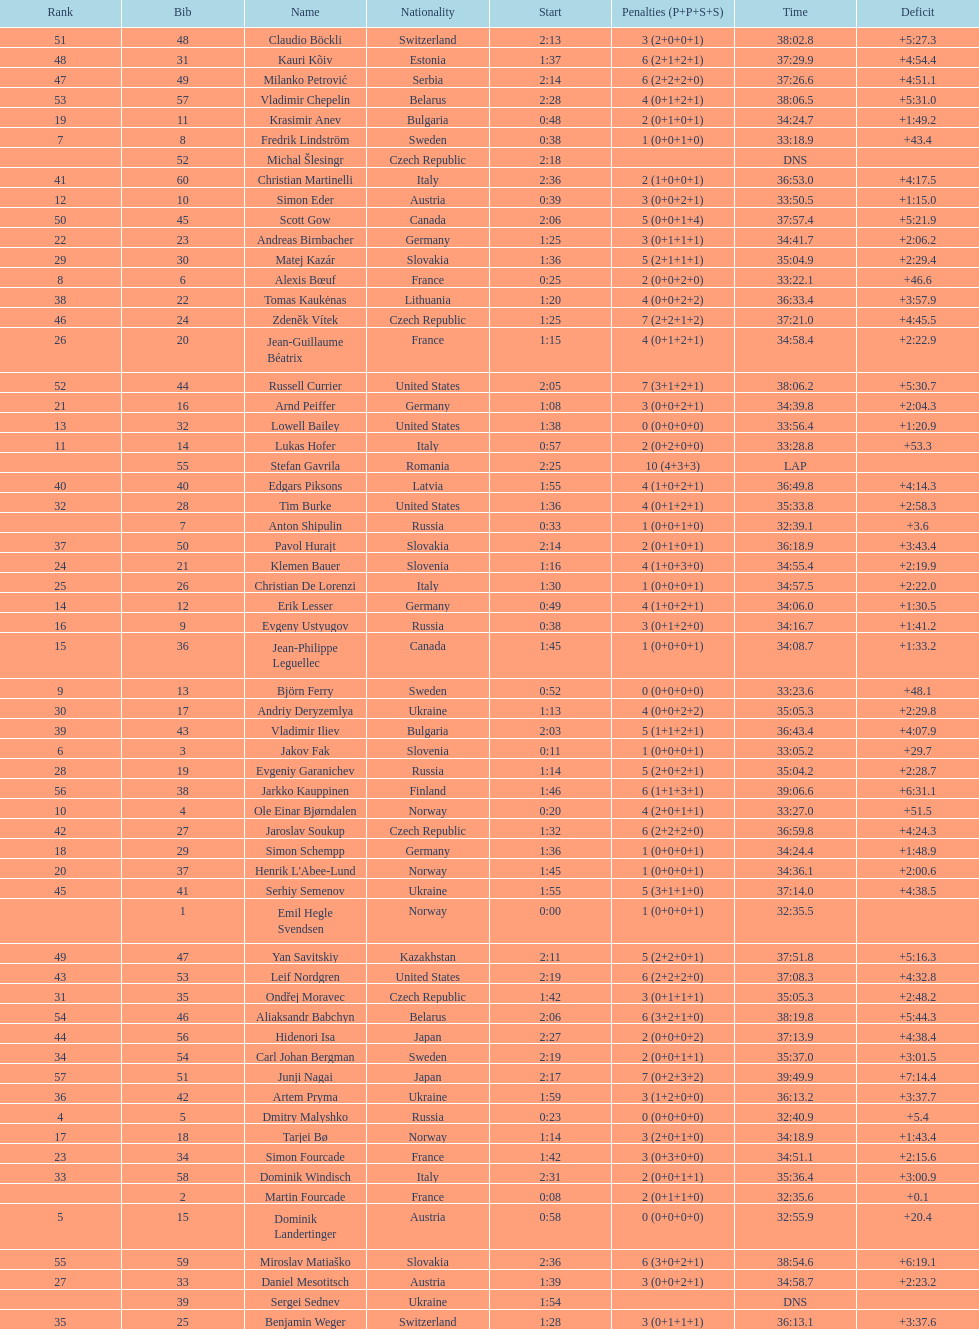What is the number of russian participants? 4. Write the full table. {'header': ['Rank', 'Bib', 'Name', 'Nationality', 'Start', 'Penalties (P+P+S+S)', 'Time', 'Deficit'], 'rows': [['51', '48', 'Claudio Böckli', 'Switzerland', '2:13', '3 (2+0+0+1)', '38:02.8', '+5:27.3'], ['48', '31', 'Kauri Kõiv', 'Estonia', '1:37', '6 (2+1+2+1)', '37:29.9', '+4:54.4'], ['47', '49', 'Milanko Petrović', 'Serbia', '2:14', '6 (2+2+2+0)', '37:26.6', '+4:51.1'], ['53', '57', 'Vladimir Chepelin', 'Belarus', '2:28', '4 (0+1+2+1)', '38:06.5', '+5:31.0'], ['19', '11', 'Krasimir Anev', 'Bulgaria', '0:48', '2 (0+1+0+1)', '34:24.7', '+1:49.2'], ['7', '8', 'Fredrik Lindström', 'Sweden', '0:38', '1 (0+0+1+0)', '33:18.9', '+43.4'], ['', '52', 'Michal Šlesingr', 'Czech Republic', '2:18', '', 'DNS', ''], ['41', '60', 'Christian Martinelli', 'Italy', '2:36', '2 (1+0+0+1)', '36:53.0', '+4:17.5'], ['12', '10', 'Simon Eder', 'Austria', '0:39', '3 (0+0+2+1)', '33:50.5', '+1:15.0'], ['50', '45', 'Scott Gow', 'Canada', '2:06', '5 (0+0+1+4)', '37:57.4', '+5:21.9'], ['22', '23', 'Andreas Birnbacher', 'Germany', '1:25', '3 (0+1+1+1)', '34:41.7', '+2:06.2'], ['29', '30', 'Matej Kazár', 'Slovakia', '1:36', '5 (2+1+1+1)', '35:04.9', '+2:29.4'], ['8', '6', 'Alexis Bœuf', 'France', '0:25', '2 (0+0+2+0)', '33:22.1', '+46.6'], ['38', '22', 'Tomas Kaukėnas', 'Lithuania', '1:20', '4 (0+0+2+2)', '36:33.4', '+3:57.9'], ['46', '24', 'Zdeněk Vítek', 'Czech Republic', '1:25', '7 (2+2+1+2)', '37:21.0', '+4:45.5'], ['26', '20', 'Jean-Guillaume Béatrix', 'France', '1:15', '4 (0+1+2+1)', '34:58.4', '+2:22.9'], ['52', '44', 'Russell Currier', 'United States', '2:05', '7 (3+1+2+1)', '38:06.2', '+5:30.7'], ['21', '16', 'Arnd Peiffer', 'Germany', '1:08', '3 (0+0+2+1)', '34:39.8', '+2:04.3'], ['13', '32', 'Lowell Bailey', 'United States', '1:38', '0 (0+0+0+0)', '33:56.4', '+1:20.9'], ['11', '14', 'Lukas Hofer', 'Italy', '0:57', '2 (0+2+0+0)', '33:28.8', '+53.3'], ['', '55', 'Stefan Gavrila', 'Romania', '2:25', '10 (4+3+3)', 'LAP', ''], ['40', '40', 'Edgars Piksons', 'Latvia', '1:55', '4 (1+0+2+1)', '36:49.8', '+4:14.3'], ['32', '28', 'Tim Burke', 'United States', '1:36', '4 (0+1+2+1)', '35:33.8', '+2:58.3'], ['', '7', 'Anton Shipulin', 'Russia', '0:33', '1 (0+0+1+0)', '32:39.1', '+3.6'], ['37', '50', 'Pavol Hurajt', 'Slovakia', '2:14', '2 (0+1+0+1)', '36:18.9', '+3:43.4'], ['24', '21', 'Klemen Bauer', 'Slovenia', '1:16', '4 (1+0+3+0)', '34:55.4', '+2:19.9'], ['25', '26', 'Christian De Lorenzi', 'Italy', '1:30', '1 (0+0+0+1)', '34:57.5', '+2:22.0'], ['14', '12', 'Erik Lesser', 'Germany', '0:49', '4 (1+0+2+1)', '34:06.0', '+1:30.5'], ['16', '9', 'Evgeny Ustyugov', 'Russia', '0:38', '3 (0+1+2+0)', '34:16.7', '+1:41.2'], ['15', '36', 'Jean-Philippe Leguellec', 'Canada', '1:45', '1 (0+0+0+1)', '34:08.7', '+1:33.2'], ['9', '13', 'Björn Ferry', 'Sweden', '0:52', '0 (0+0+0+0)', '33:23.6', '+48.1'], ['30', '17', 'Andriy Deryzemlya', 'Ukraine', '1:13', '4 (0+0+2+2)', '35:05.3', '+2:29.8'], ['39', '43', 'Vladimir Iliev', 'Bulgaria', '2:03', '5 (1+1+2+1)', '36:43.4', '+4:07.9'], ['6', '3', 'Jakov Fak', 'Slovenia', '0:11', '1 (0+0+0+1)', '33:05.2', '+29.7'], ['28', '19', 'Evgeniy Garanichev', 'Russia', '1:14', '5 (2+0+2+1)', '35:04.2', '+2:28.7'], ['56', '38', 'Jarkko Kauppinen', 'Finland', '1:46', '6 (1+1+3+1)', '39:06.6', '+6:31.1'], ['10', '4', 'Ole Einar Bjørndalen', 'Norway', '0:20', '4 (2+0+1+1)', '33:27.0', '+51.5'], ['42', '27', 'Jaroslav Soukup', 'Czech Republic', '1:32', '6 (2+2+2+0)', '36:59.8', '+4:24.3'], ['18', '29', 'Simon Schempp', 'Germany', '1:36', '1 (0+0+0+1)', '34:24.4', '+1:48.9'], ['20', '37', "Henrik L'Abee-Lund", 'Norway', '1:45', '1 (0+0+0+1)', '34:36.1', '+2:00.6'], ['45', '41', 'Serhiy Semenov', 'Ukraine', '1:55', '5 (3+1+1+0)', '37:14.0', '+4:38.5'], ['', '1', 'Emil Hegle Svendsen', 'Norway', '0:00', '1 (0+0+0+1)', '32:35.5', ''], ['49', '47', 'Yan Savitskiy', 'Kazakhstan', '2:11', '5 (2+2+0+1)', '37:51.8', '+5:16.3'], ['43', '53', 'Leif Nordgren', 'United States', '2:19', '6 (2+2+2+0)', '37:08.3', '+4:32.8'], ['31', '35', 'Ondřej Moravec', 'Czech Republic', '1:42', '3 (0+1+1+1)', '35:05.3', '+2:48.2'], ['54', '46', 'Aliaksandr Babchyn', 'Belarus', '2:06', '6 (3+2+1+0)', '38:19.8', '+5:44.3'], ['44', '56', 'Hidenori Isa', 'Japan', '2:27', '2 (0+0+0+2)', '37:13.9', '+4:38.4'], ['34', '54', 'Carl Johan Bergman', 'Sweden', '2:19', '2 (0+0+1+1)', '35:37.0', '+3:01.5'], ['57', '51', 'Junji Nagai', 'Japan', '2:17', '7 (0+2+3+2)', '39:49.9', '+7:14.4'], ['36', '42', 'Artem Pryma', 'Ukraine', '1:59', '3 (1+2+0+0)', '36:13.2', '+3:37.7'], ['4', '5', 'Dmitry Malyshko', 'Russia', '0:23', '0 (0+0+0+0)', '32:40.9', '+5.4'], ['17', '18', 'Tarjei Bø', 'Norway', '1:14', '3 (2+0+1+0)', '34:18.9', '+1:43.4'], ['23', '34', 'Simon Fourcade', 'France', '1:42', '3 (0+3+0+0)', '34:51.1', '+2:15.6'], ['33', '58', 'Dominik Windisch', 'Italy', '2:31', '2 (0+0+1+1)', '35:36.4', '+3:00.9'], ['', '2', 'Martin Fourcade', 'France', '0:08', '2 (0+1+1+0)', '32:35.6', '+0.1'], ['5', '15', 'Dominik Landertinger', 'Austria', '0:58', '0 (0+0+0+0)', '32:55.9', '+20.4'], ['55', '59', 'Miroslav Matiaško', 'Slovakia', '2:36', '6 (3+0+2+1)', '38:54.6', '+6:19.1'], ['27', '33', 'Daniel Mesotitsch', 'Austria', '1:39', '3 (0+0+2+1)', '34:58.7', '+2:23.2'], ['', '39', 'Sergei Sednev', 'Ukraine', '1:54', '', 'DNS', ''], ['35', '25', 'Benjamin Weger', 'Switzerland', '1:28', '3 (0+1+1+1)', '36:13.1', '+3:37.6']]} 